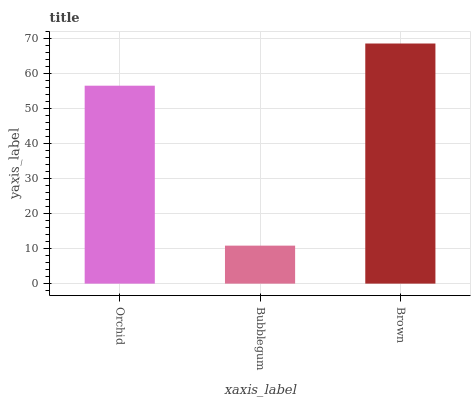Is Bubblegum the minimum?
Answer yes or no. Yes. Is Brown the maximum?
Answer yes or no. Yes. Is Brown the minimum?
Answer yes or no. No. Is Bubblegum the maximum?
Answer yes or no. No. Is Brown greater than Bubblegum?
Answer yes or no. Yes. Is Bubblegum less than Brown?
Answer yes or no. Yes. Is Bubblegum greater than Brown?
Answer yes or no. No. Is Brown less than Bubblegum?
Answer yes or no. No. Is Orchid the high median?
Answer yes or no. Yes. Is Orchid the low median?
Answer yes or no. Yes. Is Brown the high median?
Answer yes or no. No. Is Bubblegum the low median?
Answer yes or no. No. 